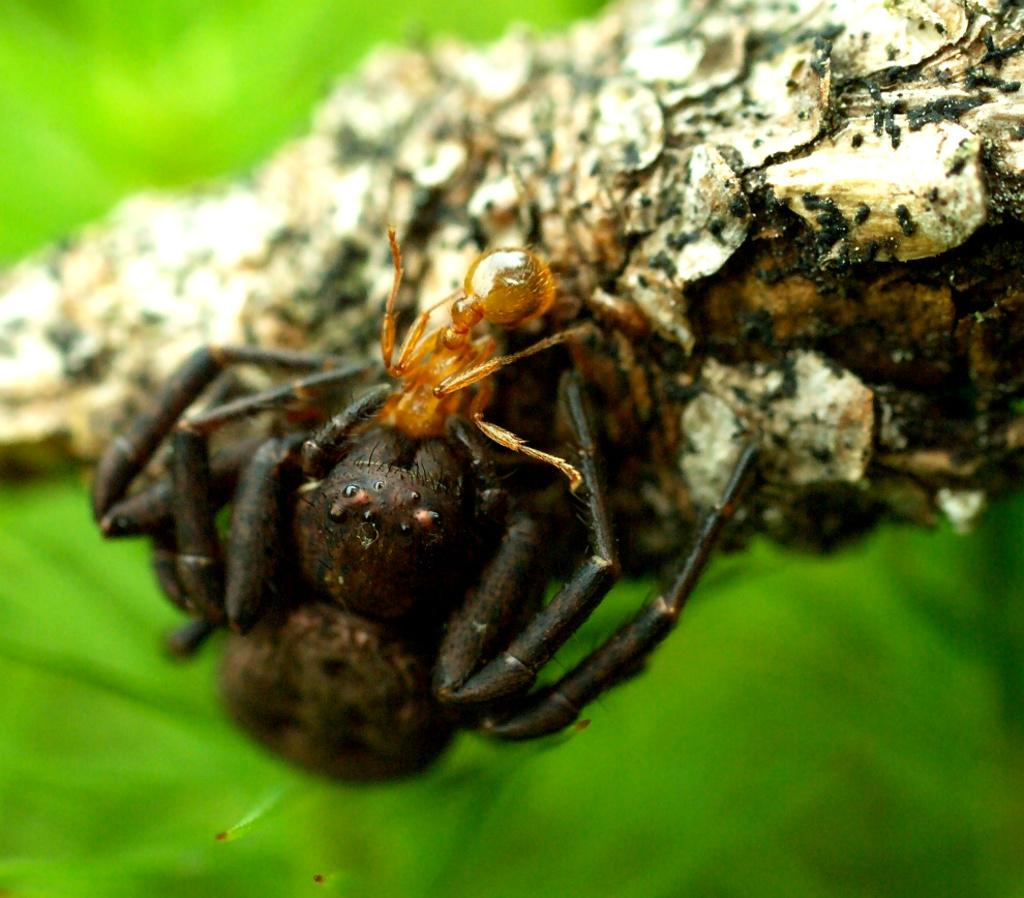What type of insects can be seen in the image? There is a spider and an ant in the image. Can you describe the background of the image? The background of the image is blurry. What type of order does the spider belong to in the image? There is no information about the order of the spider in the image. What type of lace can be seen on the spider's web in the image? There is no lace present in the image, as it is a close-up of the spider and the ant, and no web is visible. 